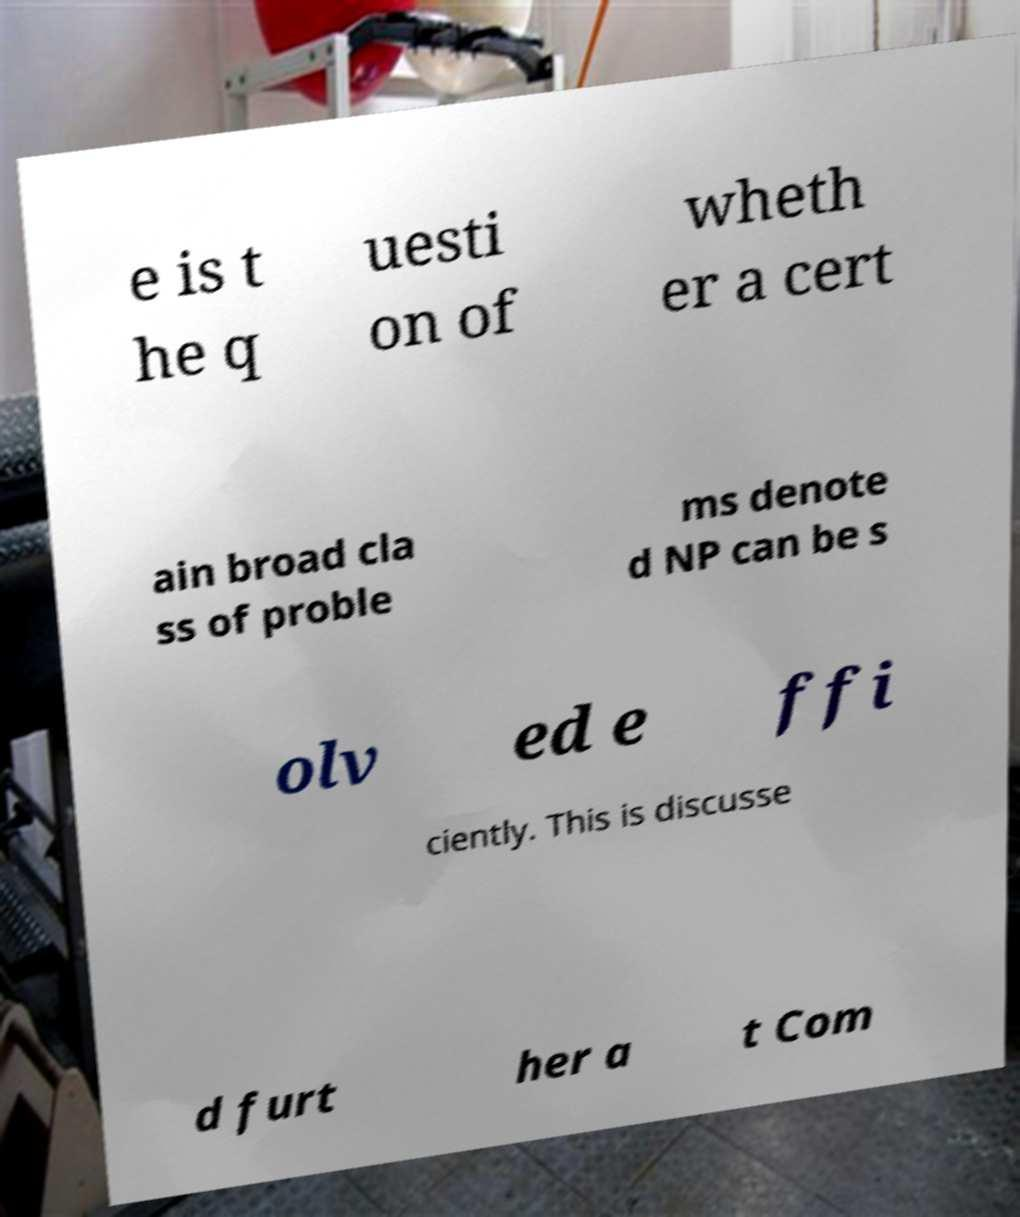Please identify and transcribe the text found in this image. e is t he q uesti on of wheth er a cert ain broad cla ss of proble ms denote d NP can be s olv ed e ffi ciently. This is discusse d furt her a t Com 